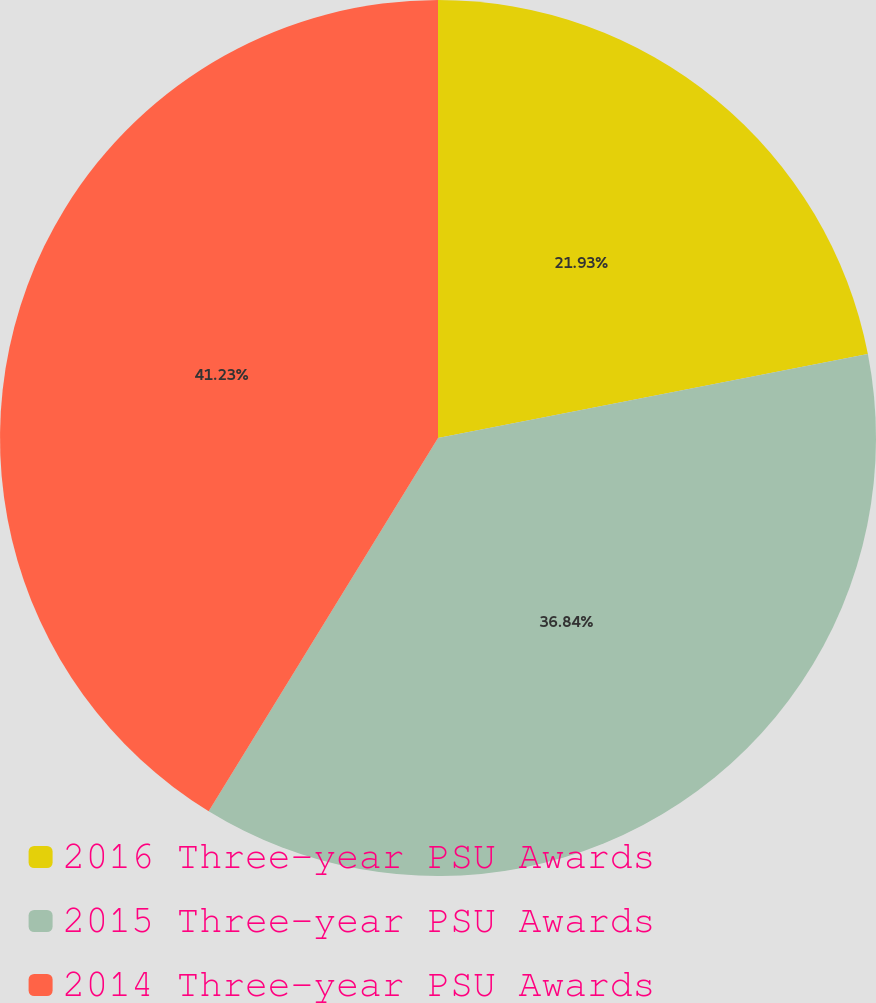Convert chart to OTSL. <chart><loc_0><loc_0><loc_500><loc_500><pie_chart><fcel>2016 Three-year PSU Awards<fcel>2015 Three-year PSU Awards<fcel>2014 Three-year PSU Awards<nl><fcel>21.93%<fcel>36.84%<fcel>41.23%<nl></chart> 